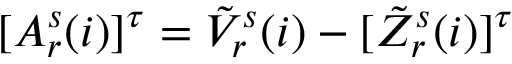Convert formula to latex. <formula><loc_0><loc_0><loc_500><loc_500>\begin{array} { r } { [ A _ { r } ^ { s } ( i ) ] ^ { \tau } = \tilde { V } _ { r } ^ { s } ( i ) - [ \tilde { Z } _ { r } ^ { s } ( i ) ] ^ { \tau } } \end{array}</formula> 